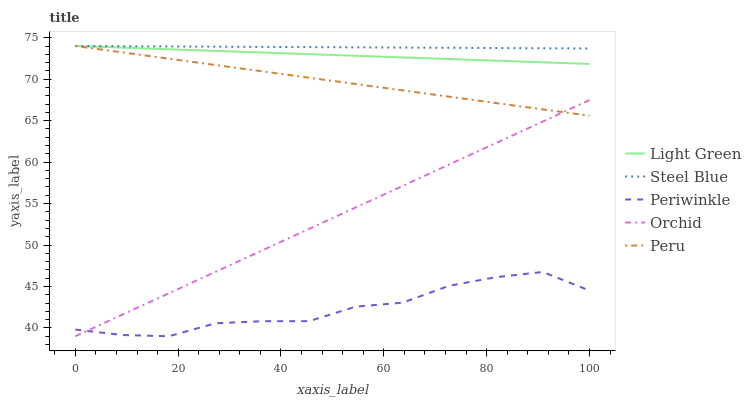Does Periwinkle have the minimum area under the curve?
Answer yes or no. Yes. Does Steel Blue have the maximum area under the curve?
Answer yes or no. Yes. Does Steel Blue have the minimum area under the curve?
Answer yes or no. No. Does Periwinkle have the maximum area under the curve?
Answer yes or no. No. Is Steel Blue the smoothest?
Answer yes or no. Yes. Is Periwinkle the roughest?
Answer yes or no. Yes. Is Periwinkle the smoothest?
Answer yes or no. No. Is Steel Blue the roughest?
Answer yes or no. No. Does Periwinkle have the lowest value?
Answer yes or no. Yes. Does Steel Blue have the lowest value?
Answer yes or no. No. Does Light Green have the highest value?
Answer yes or no. Yes. Does Periwinkle have the highest value?
Answer yes or no. No. Is Periwinkle less than Peru?
Answer yes or no. Yes. Is Light Green greater than Periwinkle?
Answer yes or no. Yes. Does Steel Blue intersect Peru?
Answer yes or no. Yes. Is Steel Blue less than Peru?
Answer yes or no. No. Is Steel Blue greater than Peru?
Answer yes or no. No. Does Periwinkle intersect Peru?
Answer yes or no. No. 